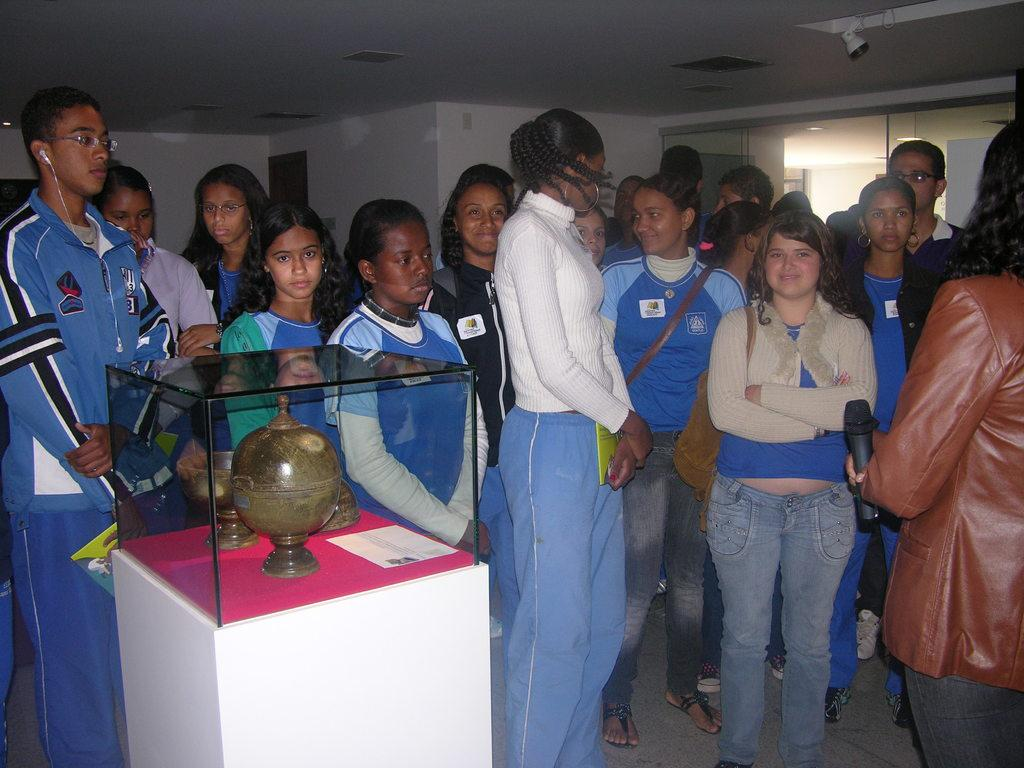How many people can be seen in the image? There are many people standing in the image. What is located on the table in the image? There is a table in the image, and there are items present in a glass box on the table. What is beside the table in the image? There is a door beside the table in the image. What type of bird can be seen flying over the people in the image? There is no bird present in the image; it only shows people standing and a table with a glass box. What print is visible on the door beside the table? There is no print visible on the door in the image; it only shows a door beside the table. 